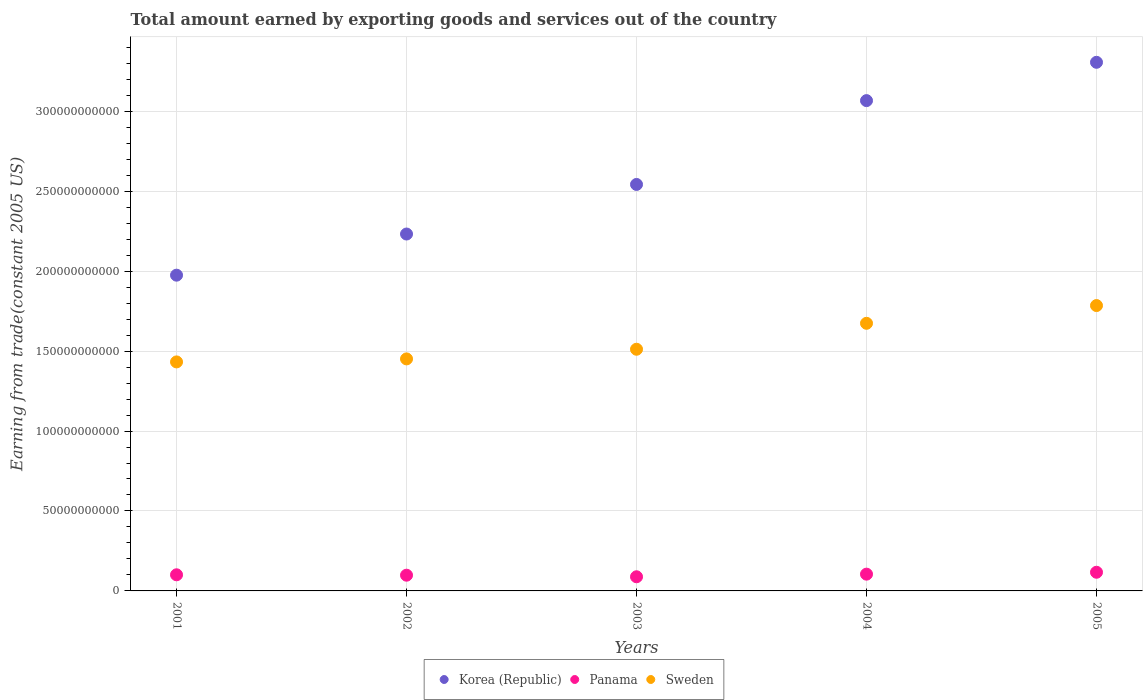How many different coloured dotlines are there?
Ensure brevity in your answer.  3. What is the total amount earned by exporting goods and services in Panama in 2002?
Ensure brevity in your answer.  9.84e+09. Across all years, what is the maximum total amount earned by exporting goods and services in Panama?
Give a very brief answer. 1.17e+1. Across all years, what is the minimum total amount earned by exporting goods and services in Panama?
Your answer should be very brief. 8.85e+09. In which year was the total amount earned by exporting goods and services in Sweden maximum?
Provide a succinct answer. 2005. In which year was the total amount earned by exporting goods and services in Korea (Republic) minimum?
Your answer should be compact. 2001. What is the total total amount earned by exporting goods and services in Sweden in the graph?
Keep it short and to the point. 7.85e+11. What is the difference between the total amount earned by exporting goods and services in Korea (Republic) in 2001 and that in 2002?
Offer a terse response. -2.57e+1. What is the difference between the total amount earned by exporting goods and services in Sweden in 2002 and the total amount earned by exporting goods and services in Korea (Republic) in 2001?
Make the answer very short. -5.24e+1. What is the average total amount earned by exporting goods and services in Panama per year?
Offer a very short reply. 1.02e+1. In the year 2004, what is the difference between the total amount earned by exporting goods and services in Panama and total amount earned by exporting goods and services in Sweden?
Offer a terse response. -1.57e+11. In how many years, is the total amount earned by exporting goods and services in Sweden greater than 170000000000 US$?
Ensure brevity in your answer.  1. What is the ratio of the total amount earned by exporting goods and services in Panama in 2001 to that in 2005?
Your response must be concise. 0.86. What is the difference between the highest and the second highest total amount earned by exporting goods and services in Sweden?
Make the answer very short. 1.11e+1. What is the difference between the highest and the lowest total amount earned by exporting goods and services in Korea (Republic)?
Ensure brevity in your answer.  1.33e+11. Is the sum of the total amount earned by exporting goods and services in Panama in 2004 and 2005 greater than the maximum total amount earned by exporting goods and services in Korea (Republic) across all years?
Your response must be concise. No. Is the total amount earned by exporting goods and services in Korea (Republic) strictly greater than the total amount earned by exporting goods and services in Sweden over the years?
Make the answer very short. Yes. Is the total amount earned by exporting goods and services in Panama strictly less than the total amount earned by exporting goods and services in Sweden over the years?
Your response must be concise. Yes. How many dotlines are there?
Ensure brevity in your answer.  3. How many years are there in the graph?
Keep it short and to the point. 5. What is the difference between two consecutive major ticks on the Y-axis?
Make the answer very short. 5.00e+1. Are the values on the major ticks of Y-axis written in scientific E-notation?
Make the answer very short. No. Does the graph contain any zero values?
Your answer should be compact. No. Does the graph contain grids?
Your response must be concise. Yes. Where does the legend appear in the graph?
Give a very brief answer. Bottom center. How many legend labels are there?
Provide a succinct answer. 3. How are the legend labels stacked?
Your response must be concise. Horizontal. What is the title of the graph?
Ensure brevity in your answer.  Total amount earned by exporting goods and services out of the country. Does "Swaziland" appear as one of the legend labels in the graph?
Provide a short and direct response. No. What is the label or title of the Y-axis?
Offer a very short reply. Earning from trade(constant 2005 US). What is the Earning from trade(constant 2005 US) in Korea (Republic) in 2001?
Provide a short and direct response. 1.97e+11. What is the Earning from trade(constant 2005 US) of Panama in 2001?
Your response must be concise. 1.01e+1. What is the Earning from trade(constant 2005 US) of Sweden in 2001?
Offer a terse response. 1.43e+11. What is the Earning from trade(constant 2005 US) in Korea (Republic) in 2002?
Make the answer very short. 2.23e+11. What is the Earning from trade(constant 2005 US) of Panama in 2002?
Provide a succinct answer. 9.84e+09. What is the Earning from trade(constant 2005 US) of Sweden in 2002?
Keep it short and to the point. 1.45e+11. What is the Earning from trade(constant 2005 US) in Korea (Republic) in 2003?
Provide a short and direct response. 2.54e+11. What is the Earning from trade(constant 2005 US) in Panama in 2003?
Provide a succinct answer. 8.85e+09. What is the Earning from trade(constant 2005 US) of Sweden in 2003?
Your response must be concise. 1.51e+11. What is the Earning from trade(constant 2005 US) in Korea (Republic) in 2004?
Your answer should be compact. 3.07e+11. What is the Earning from trade(constant 2005 US) of Panama in 2004?
Provide a short and direct response. 1.05e+1. What is the Earning from trade(constant 2005 US) of Sweden in 2004?
Offer a very short reply. 1.67e+11. What is the Earning from trade(constant 2005 US) of Korea (Republic) in 2005?
Make the answer very short. 3.31e+11. What is the Earning from trade(constant 2005 US) of Panama in 2005?
Offer a very short reply. 1.17e+1. What is the Earning from trade(constant 2005 US) in Sweden in 2005?
Ensure brevity in your answer.  1.78e+11. Across all years, what is the maximum Earning from trade(constant 2005 US) in Korea (Republic)?
Make the answer very short. 3.31e+11. Across all years, what is the maximum Earning from trade(constant 2005 US) of Panama?
Provide a succinct answer. 1.17e+1. Across all years, what is the maximum Earning from trade(constant 2005 US) in Sweden?
Provide a short and direct response. 1.78e+11. Across all years, what is the minimum Earning from trade(constant 2005 US) in Korea (Republic)?
Ensure brevity in your answer.  1.97e+11. Across all years, what is the minimum Earning from trade(constant 2005 US) in Panama?
Keep it short and to the point. 8.85e+09. Across all years, what is the minimum Earning from trade(constant 2005 US) of Sweden?
Keep it short and to the point. 1.43e+11. What is the total Earning from trade(constant 2005 US) in Korea (Republic) in the graph?
Keep it short and to the point. 1.31e+12. What is the total Earning from trade(constant 2005 US) in Panama in the graph?
Provide a short and direct response. 5.09e+1. What is the total Earning from trade(constant 2005 US) of Sweden in the graph?
Give a very brief answer. 7.85e+11. What is the difference between the Earning from trade(constant 2005 US) of Korea (Republic) in 2001 and that in 2002?
Provide a succinct answer. -2.57e+1. What is the difference between the Earning from trade(constant 2005 US) in Panama in 2001 and that in 2002?
Offer a terse response. 2.52e+08. What is the difference between the Earning from trade(constant 2005 US) in Sweden in 2001 and that in 2002?
Offer a very short reply. -1.89e+09. What is the difference between the Earning from trade(constant 2005 US) of Korea (Republic) in 2001 and that in 2003?
Keep it short and to the point. -5.67e+1. What is the difference between the Earning from trade(constant 2005 US) of Panama in 2001 and that in 2003?
Offer a very short reply. 1.24e+09. What is the difference between the Earning from trade(constant 2005 US) in Sweden in 2001 and that in 2003?
Keep it short and to the point. -7.92e+09. What is the difference between the Earning from trade(constant 2005 US) in Korea (Republic) in 2001 and that in 2004?
Your response must be concise. -1.09e+11. What is the difference between the Earning from trade(constant 2005 US) of Panama in 2001 and that in 2004?
Offer a very short reply. -4.00e+08. What is the difference between the Earning from trade(constant 2005 US) in Sweden in 2001 and that in 2004?
Offer a very short reply. -2.41e+1. What is the difference between the Earning from trade(constant 2005 US) of Korea (Republic) in 2001 and that in 2005?
Make the answer very short. -1.33e+11. What is the difference between the Earning from trade(constant 2005 US) of Panama in 2001 and that in 2005?
Provide a succinct answer. -1.59e+09. What is the difference between the Earning from trade(constant 2005 US) in Sweden in 2001 and that in 2005?
Keep it short and to the point. -3.52e+1. What is the difference between the Earning from trade(constant 2005 US) of Korea (Republic) in 2002 and that in 2003?
Ensure brevity in your answer.  -3.10e+1. What is the difference between the Earning from trade(constant 2005 US) of Panama in 2002 and that in 2003?
Ensure brevity in your answer.  9.89e+08. What is the difference between the Earning from trade(constant 2005 US) of Sweden in 2002 and that in 2003?
Offer a terse response. -6.04e+09. What is the difference between the Earning from trade(constant 2005 US) of Korea (Republic) in 2002 and that in 2004?
Make the answer very short. -8.34e+1. What is the difference between the Earning from trade(constant 2005 US) in Panama in 2002 and that in 2004?
Your answer should be compact. -6.52e+08. What is the difference between the Earning from trade(constant 2005 US) of Sweden in 2002 and that in 2004?
Make the answer very short. -2.23e+1. What is the difference between the Earning from trade(constant 2005 US) in Korea (Republic) in 2002 and that in 2005?
Offer a terse response. -1.07e+11. What is the difference between the Earning from trade(constant 2005 US) of Panama in 2002 and that in 2005?
Provide a short and direct response. -1.84e+09. What is the difference between the Earning from trade(constant 2005 US) of Sweden in 2002 and that in 2005?
Provide a short and direct response. -3.34e+1. What is the difference between the Earning from trade(constant 2005 US) of Korea (Republic) in 2003 and that in 2004?
Your answer should be very brief. -5.24e+1. What is the difference between the Earning from trade(constant 2005 US) of Panama in 2003 and that in 2004?
Provide a succinct answer. -1.64e+09. What is the difference between the Earning from trade(constant 2005 US) of Sweden in 2003 and that in 2004?
Your response must be concise. -1.62e+1. What is the difference between the Earning from trade(constant 2005 US) of Korea (Republic) in 2003 and that in 2005?
Ensure brevity in your answer.  -7.64e+1. What is the difference between the Earning from trade(constant 2005 US) of Panama in 2003 and that in 2005?
Keep it short and to the point. -2.83e+09. What is the difference between the Earning from trade(constant 2005 US) of Sweden in 2003 and that in 2005?
Offer a very short reply. -2.73e+1. What is the difference between the Earning from trade(constant 2005 US) of Korea (Republic) in 2004 and that in 2005?
Offer a terse response. -2.40e+1. What is the difference between the Earning from trade(constant 2005 US) in Panama in 2004 and that in 2005?
Give a very brief answer. -1.19e+09. What is the difference between the Earning from trade(constant 2005 US) in Sweden in 2004 and that in 2005?
Give a very brief answer. -1.11e+1. What is the difference between the Earning from trade(constant 2005 US) in Korea (Republic) in 2001 and the Earning from trade(constant 2005 US) in Panama in 2002?
Make the answer very short. 1.88e+11. What is the difference between the Earning from trade(constant 2005 US) in Korea (Republic) in 2001 and the Earning from trade(constant 2005 US) in Sweden in 2002?
Make the answer very short. 5.24e+1. What is the difference between the Earning from trade(constant 2005 US) of Panama in 2001 and the Earning from trade(constant 2005 US) of Sweden in 2002?
Offer a terse response. -1.35e+11. What is the difference between the Earning from trade(constant 2005 US) of Korea (Republic) in 2001 and the Earning from trade(constant 2005 US) of Panama in 2003?
Your response must be concise. 1.89e+11. What is the difference between the Earning from trade(constant 2005 US) of Korea (Republic) in 2001 and the Earning from trade(constant 2005 US) of Sweden in 2003?
Your answer should be compact. 4.63e+1. What is the difference between the Earning from trade(constant 2005 US) in Panama in 2001 and the Earning from trade(constant 2005 US) in Sweden in 2003?
Give a very brief answer. -1.41e+11. What is the difference between the Earning from trade(constant 2005 US) of Korea (Republic) in 2001 and the Earning from trade(constant 2005 US) of Panama in 2004?
Keep it short and to the point. 1.87e+11. What is the difference between the Earning from trade(constant 2005 US) of Korea (Republic) in 2001 and the Earning from trade(constant 2005 US) of Sweden in 2004?
Ensure brevity in your answer.  3.01e+1. What is the difference between the Earning from trade(constant 2005 US) in Panama in 2001 and the Earning from trade(constant 2005 US) in Sweden in 2004?
Offer a terse response. -1.57e+11. What is the difference between the Earning from trade(constant 2005 US) of Korea (Republic) in 2001 and the Earning from trade(constant 2005 US) of Panama in 2005?
Provide a succinct answer. 1.86e+11. What is the difference between the Earning from trade(constant 2005 US) of Korea (Republic) in 2001 and the Earning from trade(constant 2005 US) of Sweden in 2005?
Provide a succinct answer. 1.90e+1. What is the difference between the Earning from trade(constant 2005 US) in Panama in 2001 and the Earning from trade(constant 2005 US) in Sweden in 2005?
Your answer should be very brief. -1.68e+11. What is the difference between the Earning from trade(constant 2005 US) in Korea (Republic) in 2002 and the Earning from trade(constant 2005 US) in Panama in 2003?
Your answer should be very brief. 2.14e+11. What is the difference between the Earning from trade(constant 2005 US) in Korea (Republic) in 2002 and the Earning from trade(constant 2005 US) in Sweden in 2003?
Provide a succinct answer. 7.21e+1. What is the difference between the Earning from trade(constant 2005 US) of Panama in 2002 and the Earning from trade(constant 2005 US) of Sweden in 2003?
Make the answer very short. -1.41e+11. What is the difference between the Earning from trade(constant 2005 US) of Korea (Republic) in 2002 and the Earning from trade(constant 2005 US) of Panama in 2004?
Provide a succinct answer. 2.13e+11. What is the difference between the Earning from trade(constant 2005 US) of Korea (Republic) in 2002 and the Earning from trade(constant 2005 US) of Sweden in 2004?
Offer a very short reply. 5.58e+1. What is the difference between the Earning from trade(constant 2005 US) of Panama in 2002 and the Earning from trade(constant 2005 US) of Sweden in 2004?
Provide a succinct answer. -1.58e+11. What is the difference between the Earning from trade(constant 2005 US) in Korea (Republic) in 2002 and the Earning from trade(constant 2005 US) in Panama in 2005?
Your response must be concise. 2.12e+11. What is the difference between the Earning from trade(constant 2005 US) in Korea (Republic) in 2002 and the Earning from trade(constant 2005 US) in Sweden in 2005?
Your answer should be very brief. 4.47e+1. What is the difference between the Earning from trade(constant 2005 US) of Panama in 2002 and the Earning from trade(constant 2005 US) of Sweden in 2005?
Make the answer very short. -1.69e+11. What is the difference between the Earning from trade(constant 2005 US) of Korea (Republic) in 2003 and the Earning from trade(constant 2005 US) of Panama in 2004?
Your answer should be very brief. 2.44e+11. What is the difference between the Earning from trade(constant 2005 US) in Korea (Republic) in 2003 and the Earning from trade(constant 2005 US) in Sweden in 2004?
Make the answer very short. 8.68e+1. What is the difference between the Earning from trade(constant 2005 US) in Panama in 2003 and the Earning from trade(constant 2005 US) in Sweden in 2004?
Your answer should be compact. -1.59e+11. What is the difference between the Earning from trade(constant 2005 US) in Korea (Republic) in 2003 and the Earning from trade(constant 2005 US) in Panama in 2005?
Offer a very short reply. 2.43e+11. What is the difference between the Earning from trade(constant 2005 US) of Korea (Republic) in 2003 and the Earning from trade(constant 2005 US) of Sweden in 2005?
Make the answer very short. 7.57e+1. What is the difference between the Earning from trade(constant 2005 US) in Panama in 2003 and the Earning from trade(constant 2005 US) in Sweden in 2005?
Offer a very short reply. -1.70e+11. What is the difference between the Earning from trade(constant 2005 US) of Korea (Republic) in 2004 and the Earning from trade(constant 2005 US) of Panama in 2005?
Your answer should be compact. 2.95e+11. What is the difference between the Earning from trade(constant 2005 US) in Korea (Republic) in 2004 and the Earning from trade(constant 2005 US) in Sweden in 2005?
Your answer should be compact. 1.28e+11. What is the difference between the Earning from trade(constant 2005 US) in Panama in 2004 and the Earning from trade(constant 2005 US) in Sweden in 2005?
Provide a short and direct response. -1.68e+11. What is the average Earning from trade(constant 2005 US) in Korea (Republic) per year?
Keep it short and to the point. 2.62e+11. What is the average Earning from trade(constant 2005 US) in Panama per year?
Provide a succinct answer. 1.02e+1. What is the average Earning from trade(constant 2005 US) in Sweden per year?
Provide a succinct answer. 1.57e+11. In the year 2001, what is the difference between the Earning from trade(constant 2005 US) of Korea (Republic) and Earning from trade(constant 2005 US) of Panama?
Ensure brevity in your answer.  1.87e+11. In the year 2001, what is the difference between the Earning from trade(constant 2005 US) in Korea (Republic) and Earning from trade(constant 2005 US) in Sweden?
Your response must be concise. 5.42e+1. In the year 2001, what is the difference between the Earning from trade(constant 2005 US) of Panama and Earning from trade(constant 2005 US) of Sweden?
Offer a very short reply. -1.33e+11. In the year 2002, what is the difference between the Earning from trade(constant 2005 US) in Korea (Republic) and Earning from trade(constant 2005 US) in Panama?
Ensure brevity in your answer.  2.13e+11. In the year 2002, what is the difference between the Earning from trade(constant 2005 US) of Korea (Republic) and Earning from trade(constant 2005 US) of Sweden?
Provide a succinct answer. 7.81e+1. In the year 2002, what is the difference between the Earning from trade(constant 2005 US) in Panama and Earning from trade(constant 2005 US) in Sweden?
Keep it short and to the point. -1.35e+11. In the year 2003, what is the difference between the Earning from trade(constant 2005 US) of Korea (Republic) and Earning from trade(constant 2005 US) of Panama?
Offer a terse response. 2.45e+11. In the year 2003, what is the difference between the Earning from trade(constant 2005 US) in Korea (Republic) and Earning from trade(constant 2005 US) in Sweden?
Ensure brevity in your answer.  1.03e+11. In the year 2003, what is the difference between the Earning from trade(constant 2005 US) in Panama and Earning from trade(constant 2005 US) in Sweden?
Ensure brevity in your answer.  -1.42e+11. In the year 2004, what is the difference between the Earning from trade(constant 2005 US) of Korea (Republic) and Earning from trade(constant 2005 US) of Panama?
Your answer should be very brief. 2.96e+11. In the year 2004, what is the difference between the Earning from trade(constant 2005 US) of Korea (Republic) and Earning from trade(constant 2005 US) of Sweden?
Your answer should be compact. 1.39e+11. In the year 2004, what is the difference between the Earning from trade(constant 2005 US) of Panama and Earning from trade(constant 2005 US) of Sweden?
Give a very brief answer. -1.57e+11. In the year 2005, what is the difference between the Earning from trade(constant 2005 US) of Korea (Republic) and Earning from trade(constant 2005 US) of Panama?
Offer a terse response. 3.19e+11. In the year 2005, what is the difference between the Earning from trade(constant 2005 US) of Korea (Republic) and Earning from trade(constant 2005 US) of Sweden?
Your answer should be compact. 1.52e+11. In the year 2005, what is the difference between the Earning from trade(constant 2005 US) of Panama and Earning from trade(constant 2005 US) of Sweden?
Your answer should be very brief. -1.67e+11. What is the ratio of the Earning from trade(constant 2005 US) of Korea (Republic) in 2001 to that in 2002?
Keep it short and to the point. 0.88. What is the ratio of the Earning from trade(constant 2005 US) in Panama in 2001 to that in 2002?
Your response must be concise. 1.03. What is the ratio of the Earning from trade(constant 2005 US) of Sweden in 2001 to that in 2002?
Your answer should be compact. 0.99. What is the ratio of the Earning from trade(constant 2005 US) in Korea (Republic) in 2001 to that in 2003?
Your response must be concise. 0.78. What is the ratio of the Earning from trade(constant 2005 US) of Panama in 2001 to that in 2003?
Ensure brevity in your answer.  1.14. What is the ratio of the Earning from trade(constant 2005 US) of Sweden in 2001 to that in 2003?
Keep it short and to the point. 0.95. What is the ratio of the Earning from trade(constant 2005 US) of Korea (Republic) in 2001 to that in 2004?
Provide a succinct answer. 0.64. What is the ratio of the Earning from trade(constant 2005 US) in Panama in 2001 to that in 2004?
Provide a succinct answer. 0.96. What is the ratio of the Earning from trade(constant 2005 US) of Sweden in 2001 to that in 2004?
Your answer should be very brief. 0.86. What is the ratio of the Earning from trade(constant 2005 US) of Korea (Republic) in 2001 to that in 2005?
Make the answer very short. 0.6. What is the ratio of the Earning from trade(constant 2005 US) in Panama in 2001 to that in 2005?
Ensure brevity in your answer.  0.86. What is the ratio of the Earning from trade(constant 2005 US) of Sweden in 2001 to that in 2005?
Provide a succinct answer. 0.8. What is the ratio of the Earning from trade(constant 2005 US) in Korea (Republic) in 2002 to that in 2003?
Keep it short and to the point. 0.88. What is the ratio of the Earning from trade(constant 2005 US) in Panama in 2002 to that in 2003?
Offer a very short reply. 1.11. What is the ratio of the Earning from trade(constant 2005 US) in Sweden in 2002 to that in 2003?
Provide a short and direct response. 0.96. What is the ratio of the Earning from trade(constant 2005 US) in Korea (Republic) in 2002 to that in 2004?
Offer a terse response. 0.73. What is the ratio of the Earning from trade(constant 2005 US) in Panama in 2002 to that in 2004?
Provide a succinct answer. 0.94. What is the ratio of the Earning from trade(constant 2005 US) of Sweden in 2002 to that in 2004?
Your answer should be compact. 0.87. What is the ratio of the Earning from trade(constant 2005 US) in Korea (Republic) in 2002 to that in 2005?
Make the answer very short. 0.68. What is the ratio of the Earning from trade(constant 2005 US) of Panama in 2002 to that in 2005?
Your response must be concise. 0.84. What is the ratio of the Earning from trade(constant 2005 US) of Sweden in 2002 to that in 2005?
Your answer should be compact. 0.81. What is the ratio of the Earning from trade(constant 2005 US) of Korea (Republic) in 2003 to that in 2004?
Your answer should be compact. 0.83. What is the ratio of the Earning from trade(constant 2005 US) in Panama in 2003 to that in 2004?
Keep it short and to the point. 0.84. What is the ratio of the Earning from trade(constant 2005 US) of Sweden in 2003 to that in 2004?
Your response must be concise. 0.9. What is the ratio of the Earning from trade(constant 2005 US) of Korea (Republic) in 2003 to that in 2005?
Your response must be concise. 0.77. What is the ratio of the Earning from trade(constant 2005 US) of Panama in 2003 to that in 2005?
Your answer should be very brief. 0.76. What is the ratio of the Earning from trade(constant 2005 US) of Sweden in 2003 to that in 2005?
Offer a terse response. 0.85. What is the ratio of the Earning from trade(constant 2005 US) in Korea (Republic) in 2004 to that in 2005?
Provide a succinct answer. 0.93. What is the ratio of the Earning from trade(constant 2005 US) of Panama in 2004 to that in 2005?
Offer a terse response. 0.9. What is the ratio of the Earning from trade(constant 2005 US) in Sweden in 2004 to that in 2005?
Offer a very short reply. 0.94. What is the difference between the highest and the second highest Earning from trade(constant 2005 US) of Korea (Republic)?
Provide a short and direct response. 2.40e+1. What is the difference between the highest and the second highest Earning from trade(constant 2005 US) of Panama?
Make the answer very short. 1.19e+09. What is the difference between the highest and the second highest Earning from trade(constant 2005 US) in Sweden?
Offer a terse response. 1.11e+1. What is the difference between the highest and the lowest Earning from trade(constant 2005 US) in Korea (Republic)?
Your answer should be compact. 1.33e+11. What is the difference between the highest and the lowest Earning from trade(constant 2005 US) of Panama?
Provide a short and direct response. 2.83e+09. What is the difference between the highest and the lowest Earning from trade(constant 2005 US) in Sweden?
Make the answer very short. 3.52e+1. 